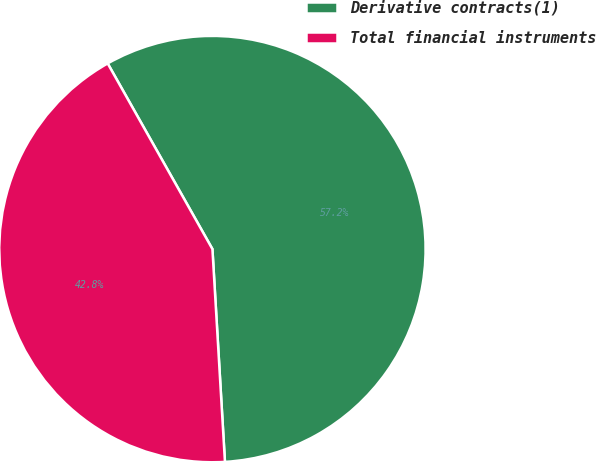Convert chart. <chart><loc_0><loc_0><loc_500><loc_500><pie_chart><fcel>Derivative contracts(1)<fcel>Total financial instruments<nl><fcel>57.24%<fcel>42.76%<nl></chart> 